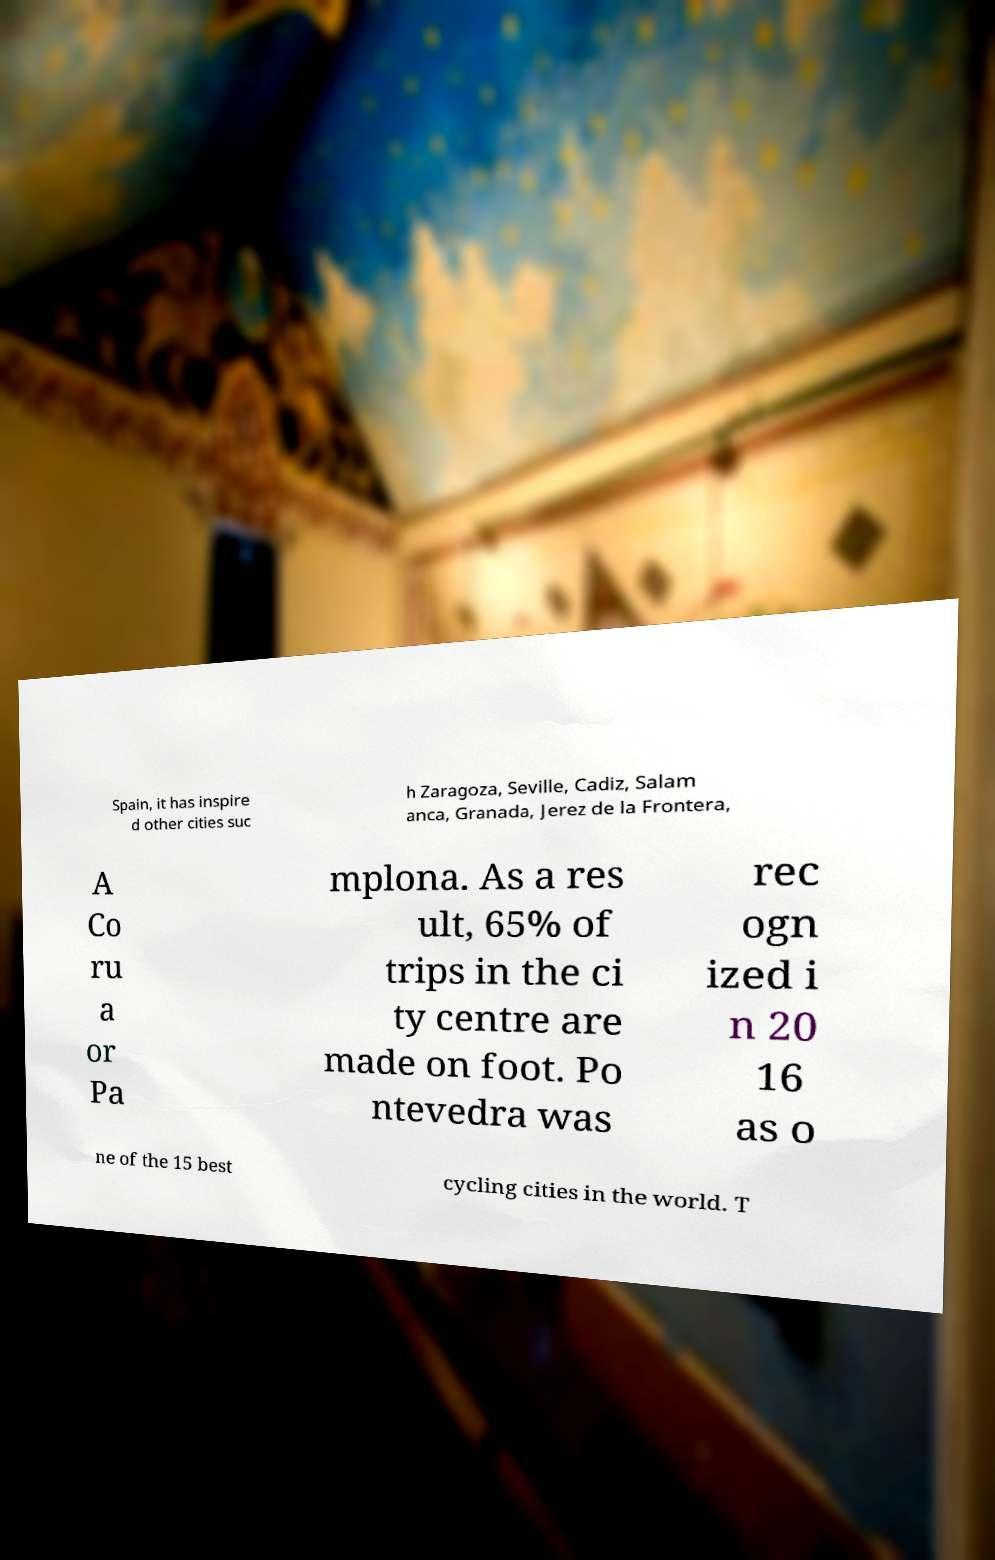What messages or text are displayed in this image? I need them in a readable, typed format. Spain, it has inspire d other cities suc h Zaragoza, Seville, Cadiz, Salam anca, Granada, Jerez de la Frontera, A Co ru a or Pa mplona. As a res ult, 65% of trips in the ci ty centre are made on foot. Po ntevedra was rec ogn ized i n 20 16 as o ne of the 15 best cycling cities in the world. T 